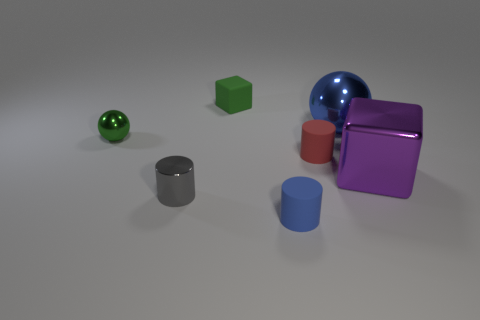Subtract all red cubes. Subtract all red cylinders. How many cubes are left? 2 Add 1 large purple things. How many objects exist? 8 Subtract all balls. How many objects are left? 5 Subtract all big blue shiny balls. Subtract all tiny objects. How many objects are left? 1 Add 3 tiny blue rubber cylinders. How many tiny blue rubber cylinders are left? 4 Add 6 purple metal things. How many purple metal things exist? 7 Subtract 0 blue blocks. How many objects are left? 7 